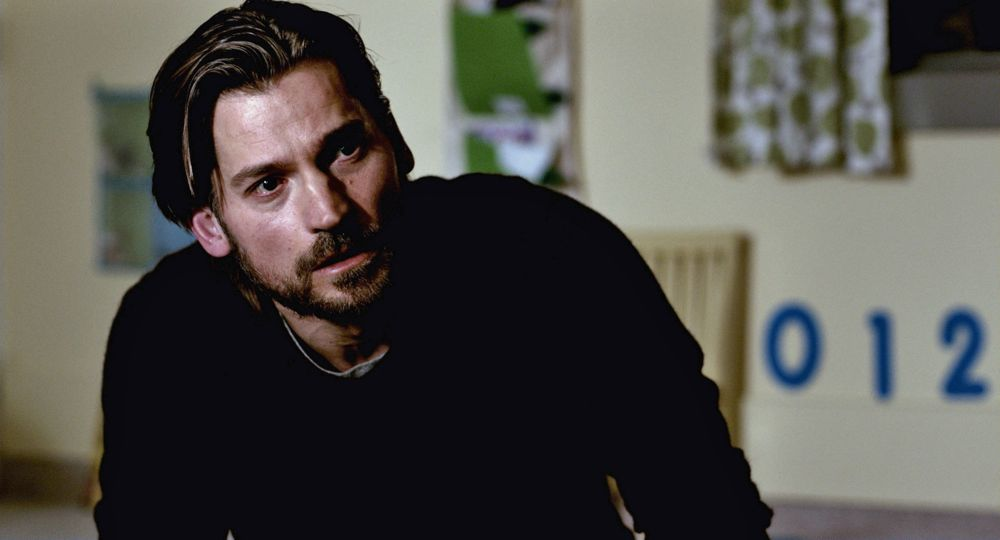Explain the visual content of the image in great detail. In this image, there is a man with a serious expression on his face. He has a rugged look with a neatly kept beard and is wearing a black sweater. His posture and the direction of his gaze suggest that he is in deep thought or listening intently to someone nearby. The background features a simple room with yellowish-green walls. Notably, there is a whiteboard or sign on the wall behind him with the numbers '012' clearly visible in blue. The room is softly lit, creating a somber and introspective mood. 